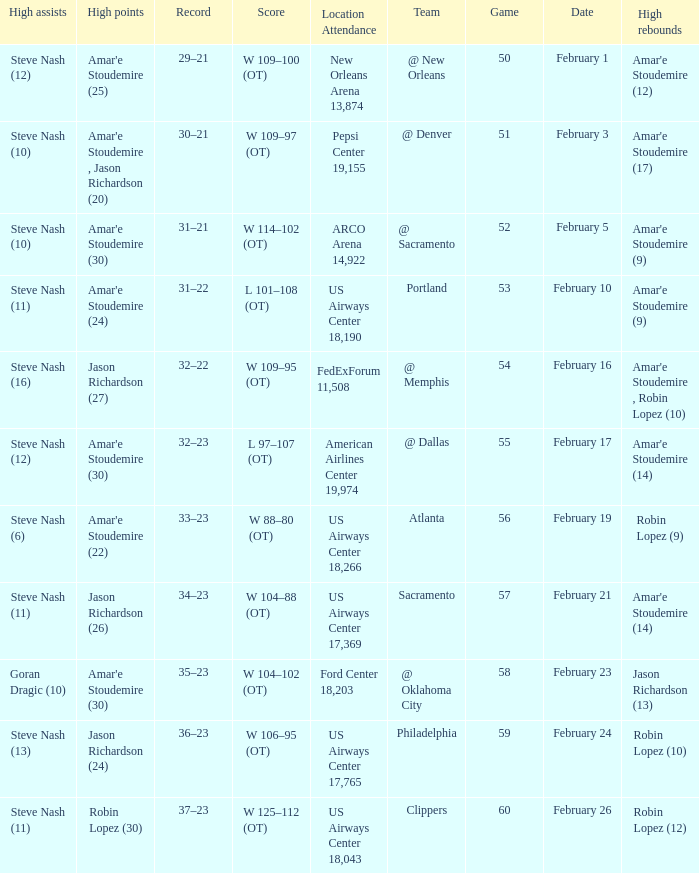Name the high points for pepsi center 19,155 Amar'e Stoudemire , Jason Richardson (20). 